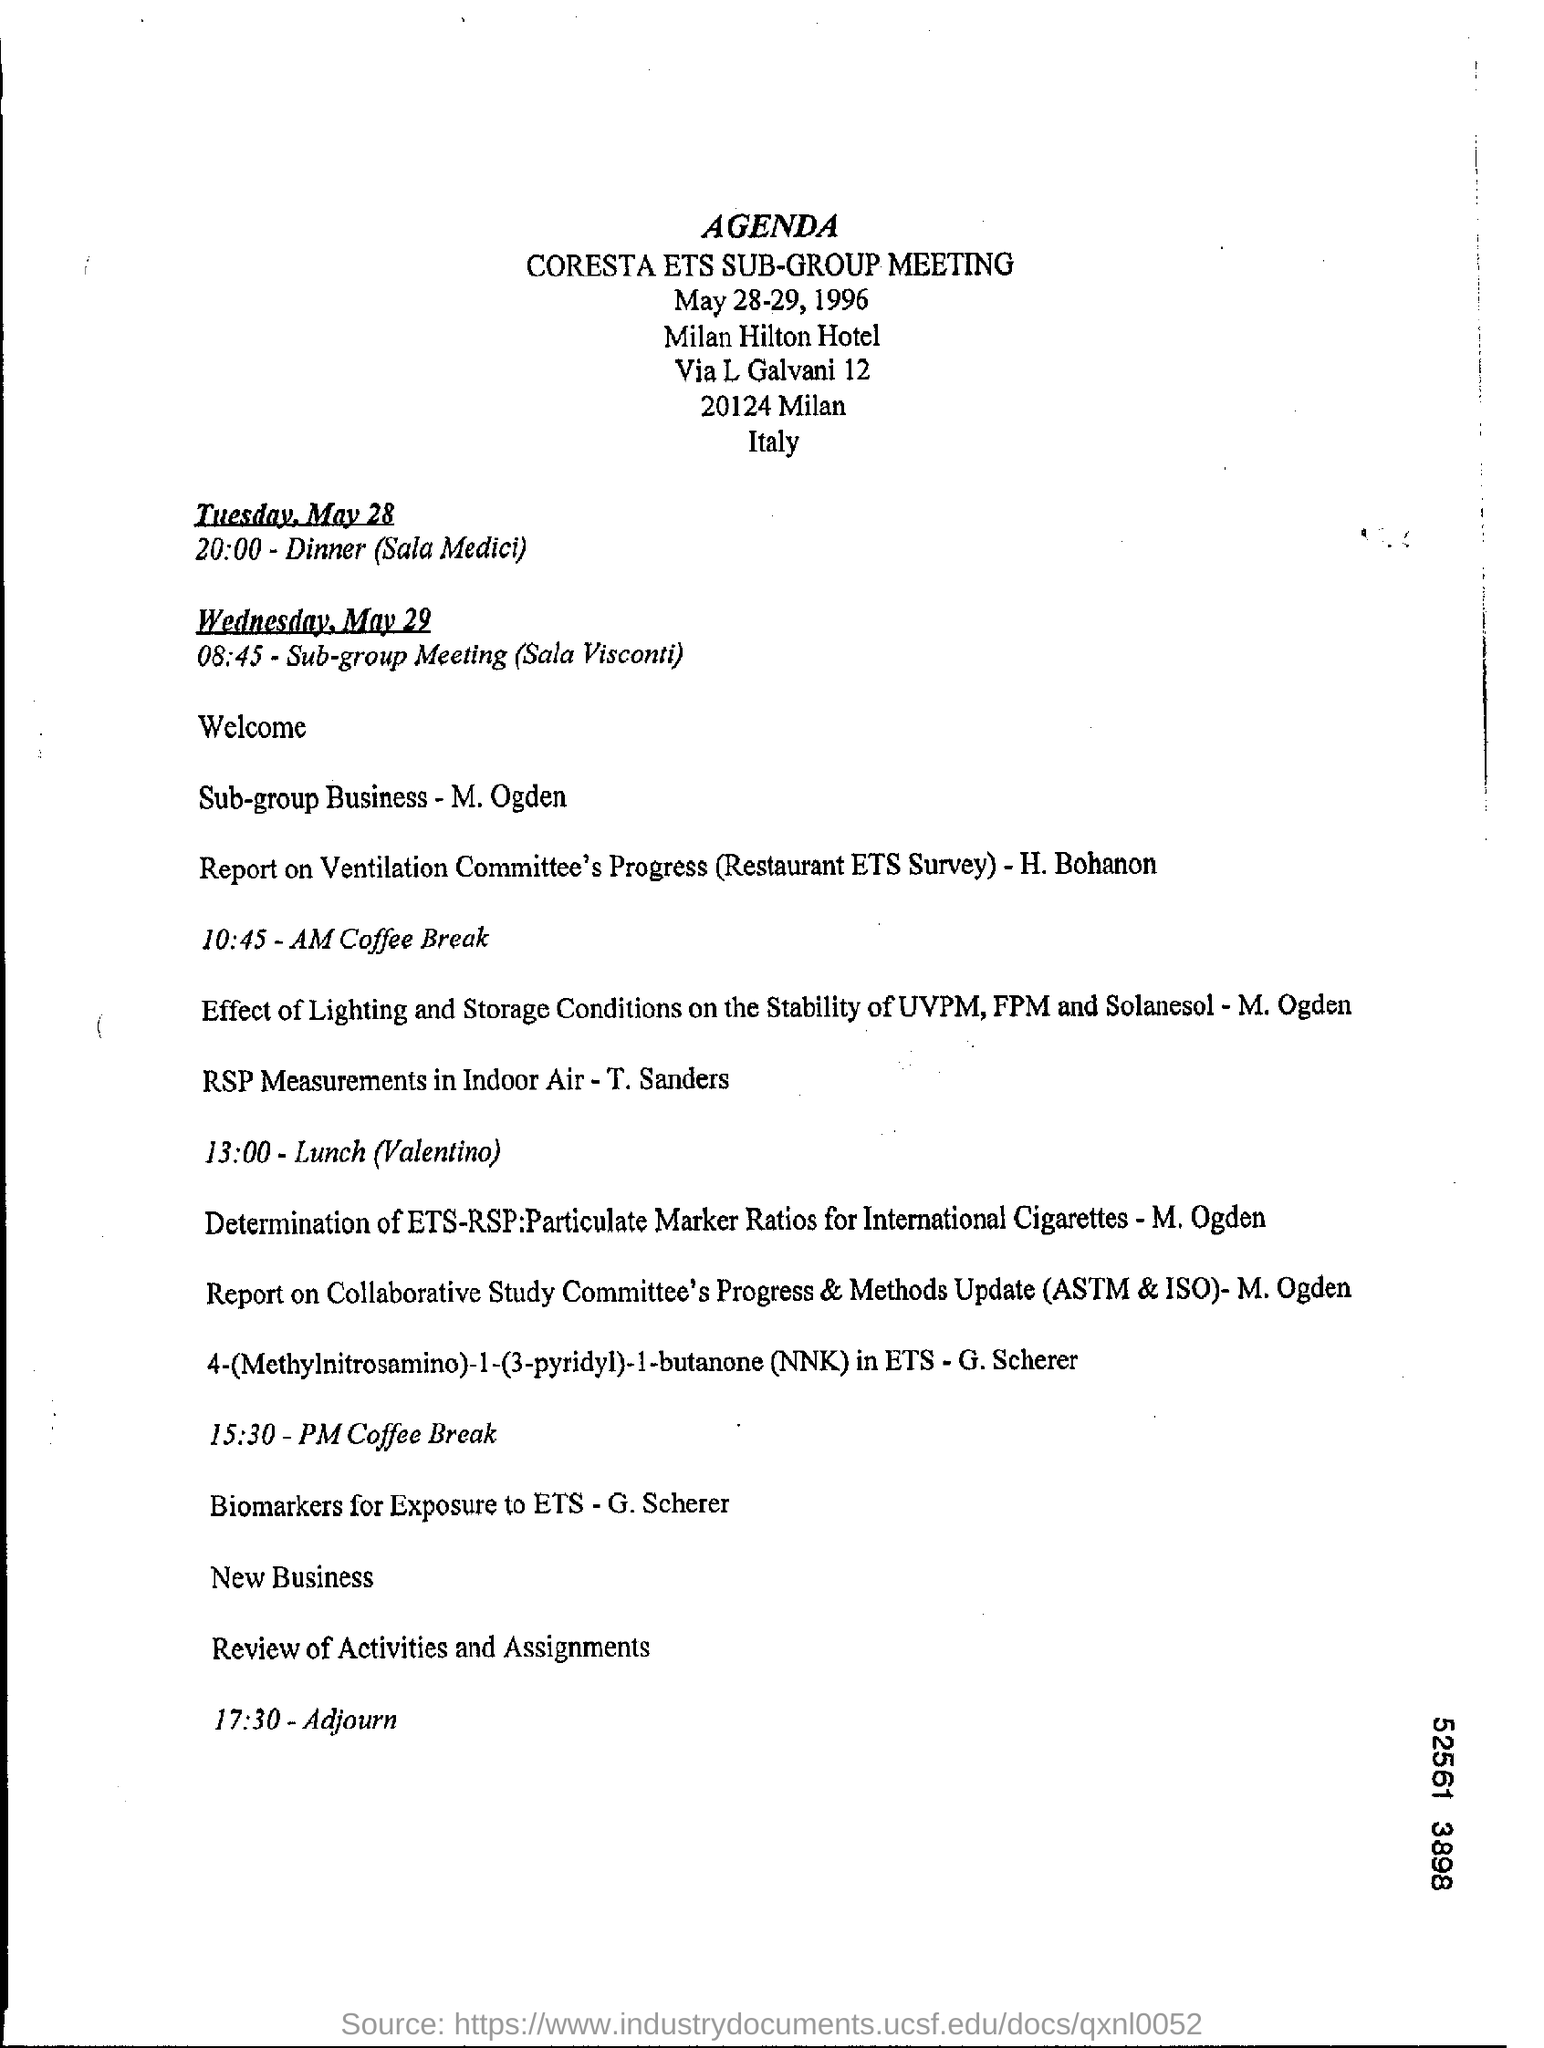Give some essential details in this illustration. The location of the CORESTA ETS SUB-GROUP MEETING has been confirmed to be held at the Milan Hilton Hotel. The sub-group meeting will start on Wednesday, May 29 at 8:45 a.m. The given text is a question asking about a specific meeting agenda. The question is asking if the document provided is the agenda for a CORESTA ETS SUB-GROUP MEETING. The meeting was adjourned at 17:30. 